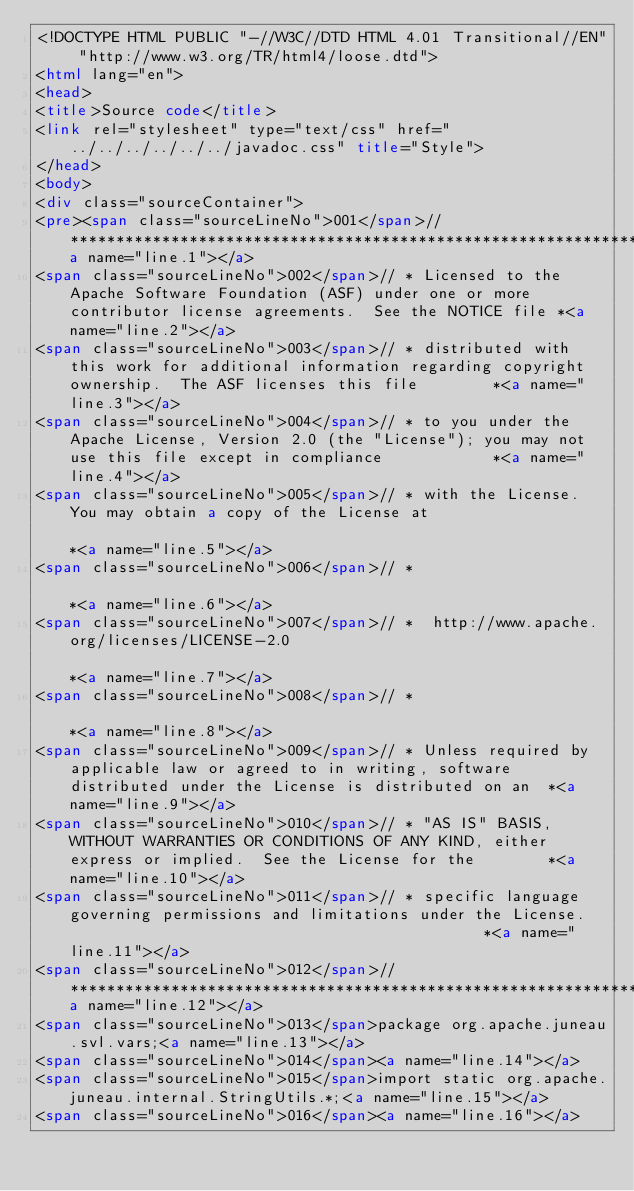Convert code to text. <code><loc_0><loc_0><loc_500><loc_500><_HTML_><!DOCTYPE HTML PUBLIC "-//W3C//DTD HTML 4.01 Transitional//EN" "http://www.w3.org/TR/html4/loose.dtd">
<html lang="en">
<head>
<title>Source code</title>
<link rel="stylesheet" type="text/css" href="../../../../../../javadoc.css" title="Style">
</head>
<body>
<div class="sourceContainer">
<pre><span class="sourceLineNo">001</span>// ***************************************************************************************************************************<a name="line.1"></a>
<span class="sourceLineNo">002</span>// * Licensed to the Apache Software Foundation (ASF) under one or more contributor license agreements.  See the NOTICE file *<a name="line.2"></a>
<span class="sourceLineNo">003</span>// * distributed with this work for additional information regarding copyright ownership.  The ASF licenses this file        *<a name="line.3"></a>
<span class="sourceLineNo">004</span>// * to you under the Apache License, Version 2.0 (the "License"); you may not use this file except in compliance            *<a name="line.4"></a>
<span class="sourceLineNo">005</span>// * with the License.  You may obtain a copy of the License at                                                              *<a name="line.5"></a>
<span class="sourceLineNo">006</span>// *                                                                                                                         *<a name="line.6"></a>
<span class="sourceLineNo">007</span>// *  http://www.apache.org/licenses/LICENSE-2.0                                                                             *<a name="line.7"></a>
<span class="sourceLineNo">008</span>// *                                                                                                                         *<a name="line.8"></a>
<span class="sourceLineNo">009</span>// * Unless required by applicable law or agreed to in writing, software distributed under the License is distributed on an  *<a name="line.9"></a>
<span class="sourceLineNo">010</span>// * "AS IS" BASIS, WITHOUT WARRANTIES OR CONDITIONS OF ANY KIND, either express or implied.  See the License for the        *<a name="line.10"></a>
<span class="sourceLineNo">011</span>// * specific language governing permissions and limitations under the License.                                              *<a name="line.11"></a>
<span class="sourceLineNo">012</span>// ***************************************************************************************************************************<a name="line.12"></a>
<span class="sourceLineNo">013</span>package org.apache.juneau.svl.vars;<a name="line.13"></a>
<span class="sourceLineNo">014</span><a name="line.14"></a>
<span class="sourceLineNo">015</span>import static org.apache.juneau.internal.StringUtils.*;<a name="line.15"></a>
<span class="sourceLineNo">016</span><a name="line.16"></a></code> 